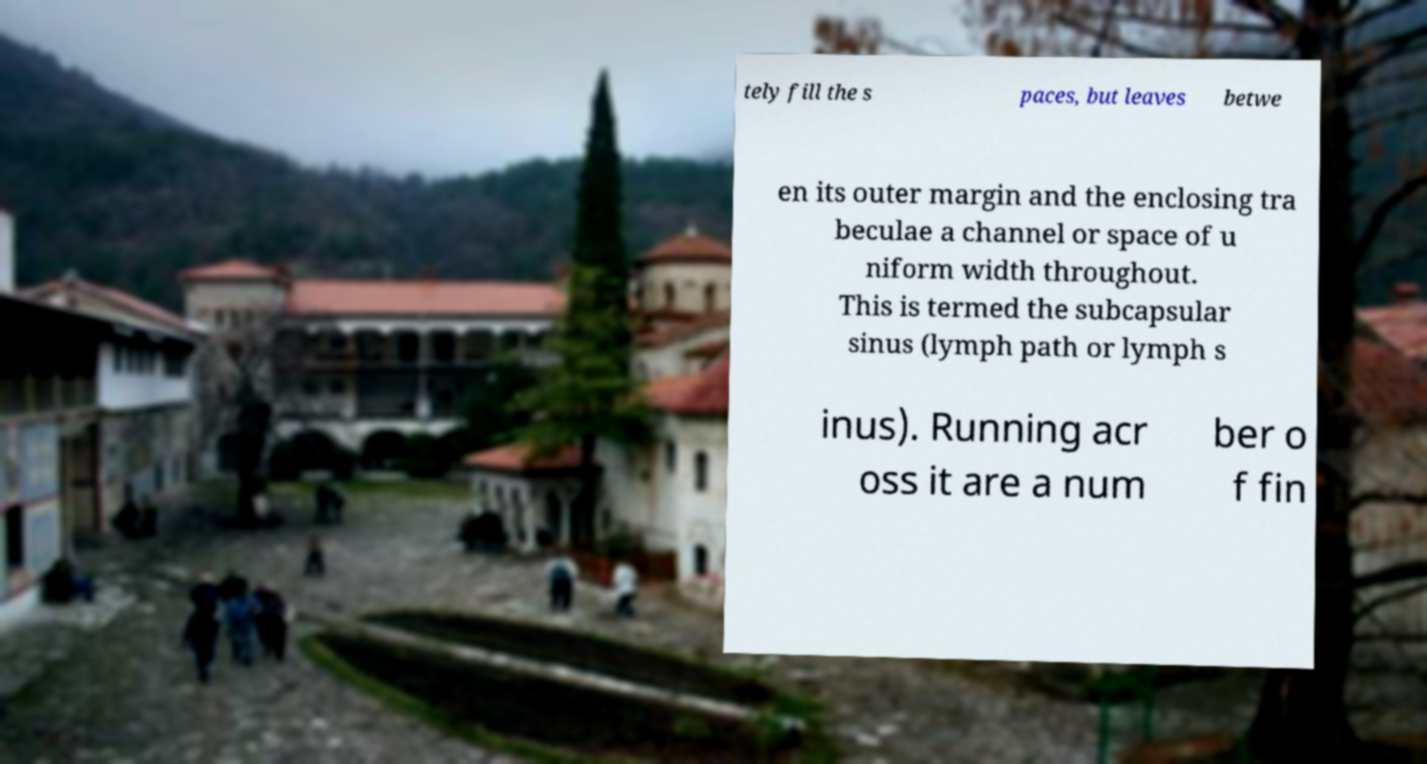Can you read and provide the text displayed in the image?This photo seems to have some interesting text. Can you extract and type it out for me? tely fill the s paces, but leaves betwe en its outer margin and the enclosing tra beculae a channel or space of u niform width throughout. This is termed the subcapsular sinus (lymph path or lymph s inus). Running acr oss it are a num ber o f fin 